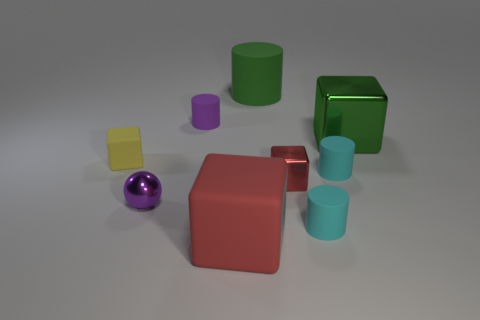Subtract all blue cylinders. Subtract all cyan balls. How many cylinders are left? 4 Add 1 tiny red shiny things. How many objects exist? 10 Subtract all spheres. How many objects are left? 8 Subtract 1 purple cylinders. How many objects are left? 8 Subtract all tiny matte blocks. Subtract all small purple cylinders. How many objects are left? 7 Add 4 tiny cyan matte objects. How many tiny cyan matte objects are left? 6 Add 6 big rubber objects. How many big rubber objects exist? 8 